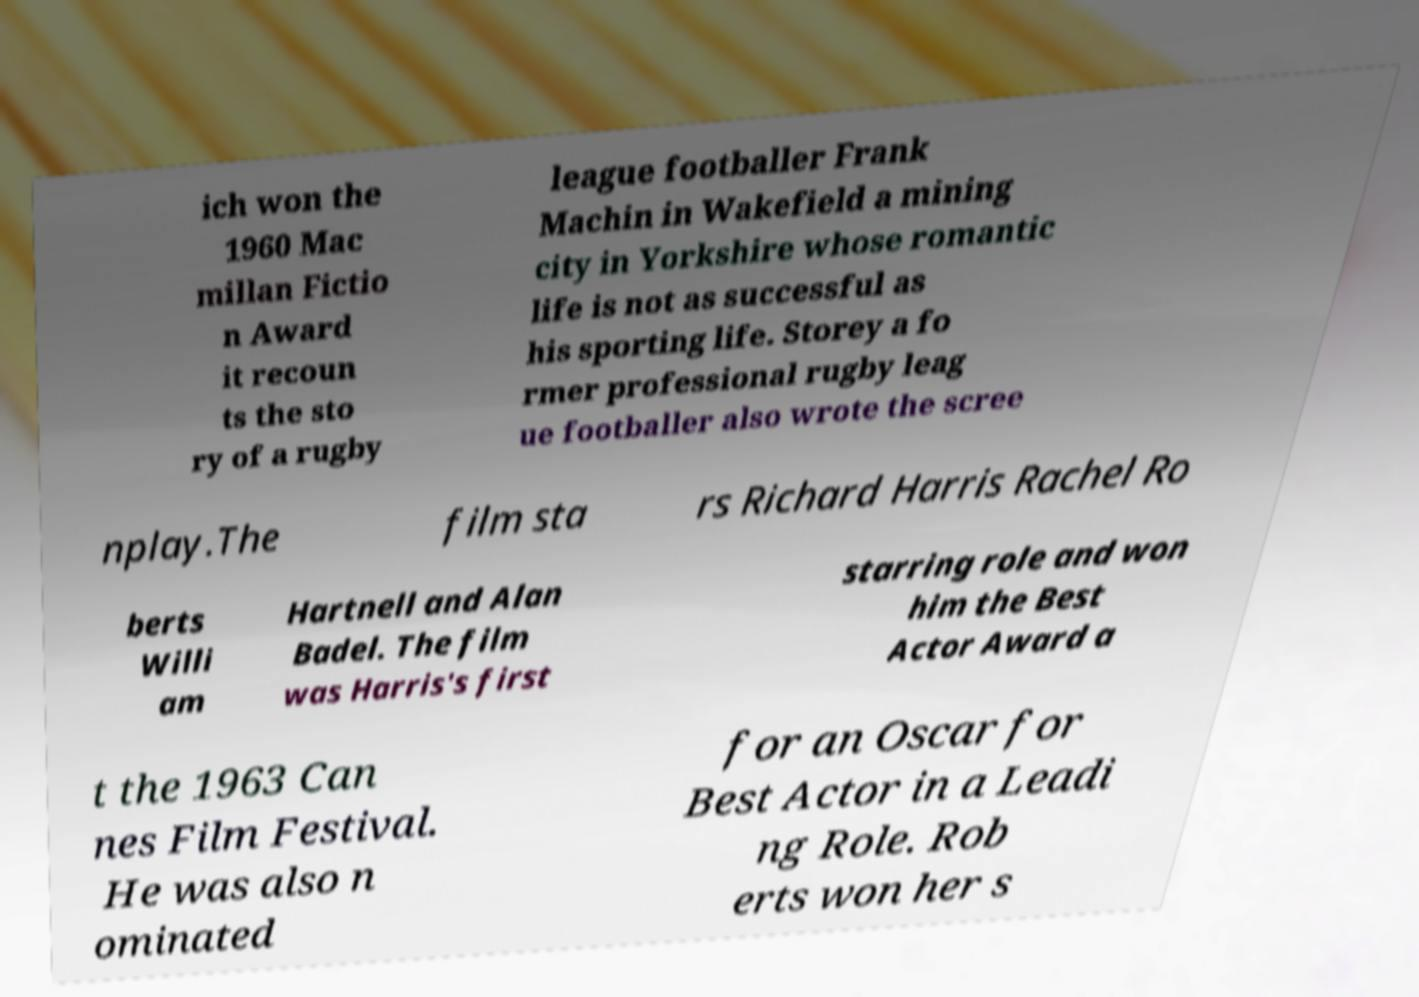What messages or text are displayed in this image? I need them in a readable, typed format. ich won the 1960 Mac millan Fictio n Award it recoun ts the sto ry of a rugby league footballer Frank Machin in Wakefield a mining city in Yorkshire whose romantic life is not as successful as his sporting life. Storey a fo rmer professional rugby leag ue footballer also wrote the scree nplay.The film sta rs Richard Harris Rachel Ro berts Willi am Hartnell and Alan Badel. The film was Harris's first starring role and won him the Best Actor Award a t the 1963 Can nes Film Festival. He was also n ominated for an Oscar for Best Actor in a Leadi ng Role. Rob erts won her s 